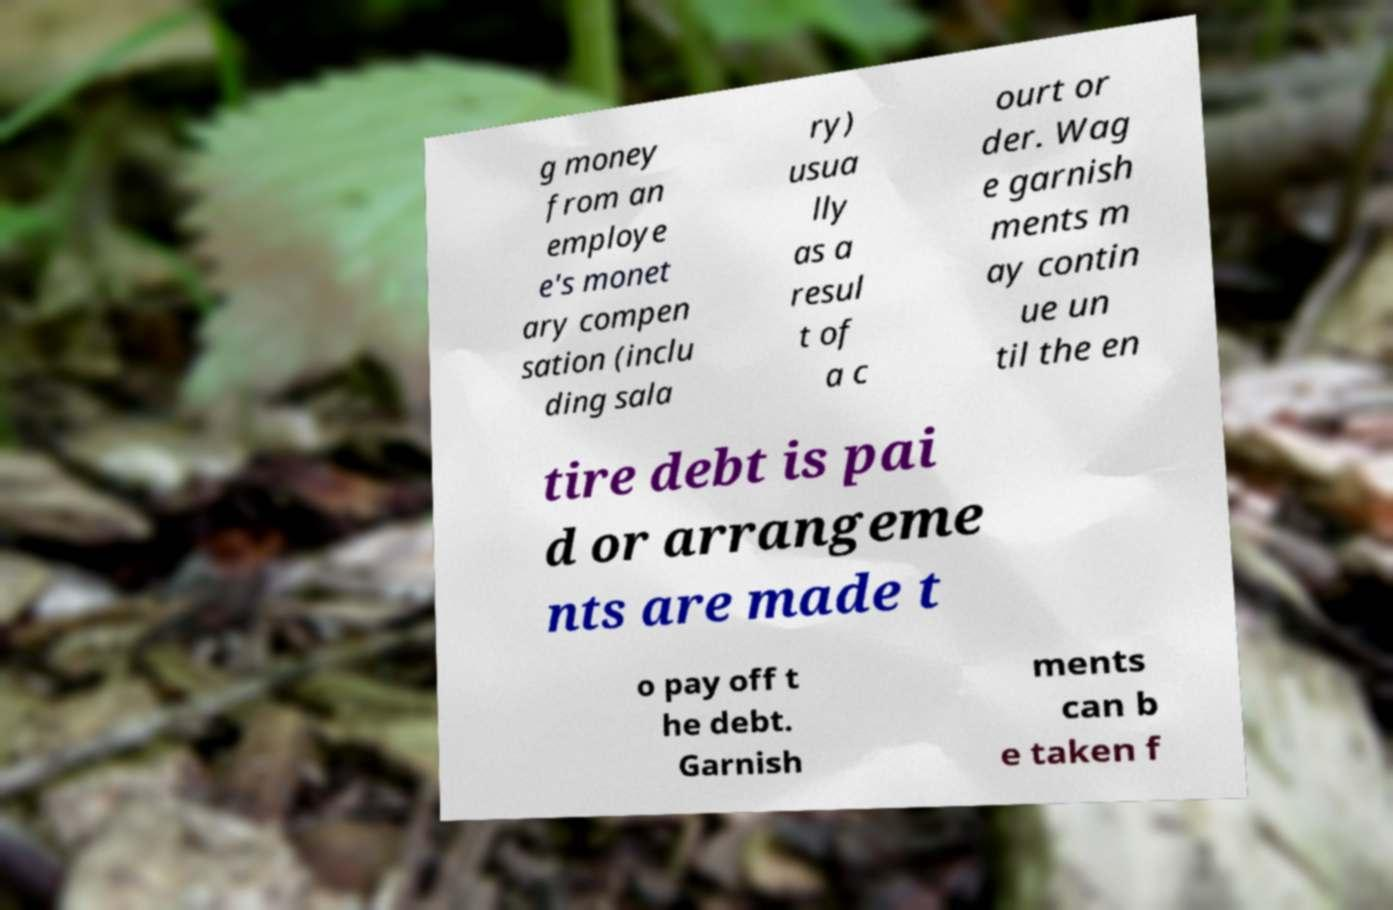Can you read and provide the text displayed in the image?This photo seems to have some interesting text. Can you extract and type it out for me? g money from an employe e's monet ary compen sation (inclu ding sala ry) usua lly as a resul t of a c ourt or der. Wag e garnish ments m ay contin ue un til the en tire debt is pai d or arrangeme nts are made t o pay off t he debt. Garnish ments can b e taken f 